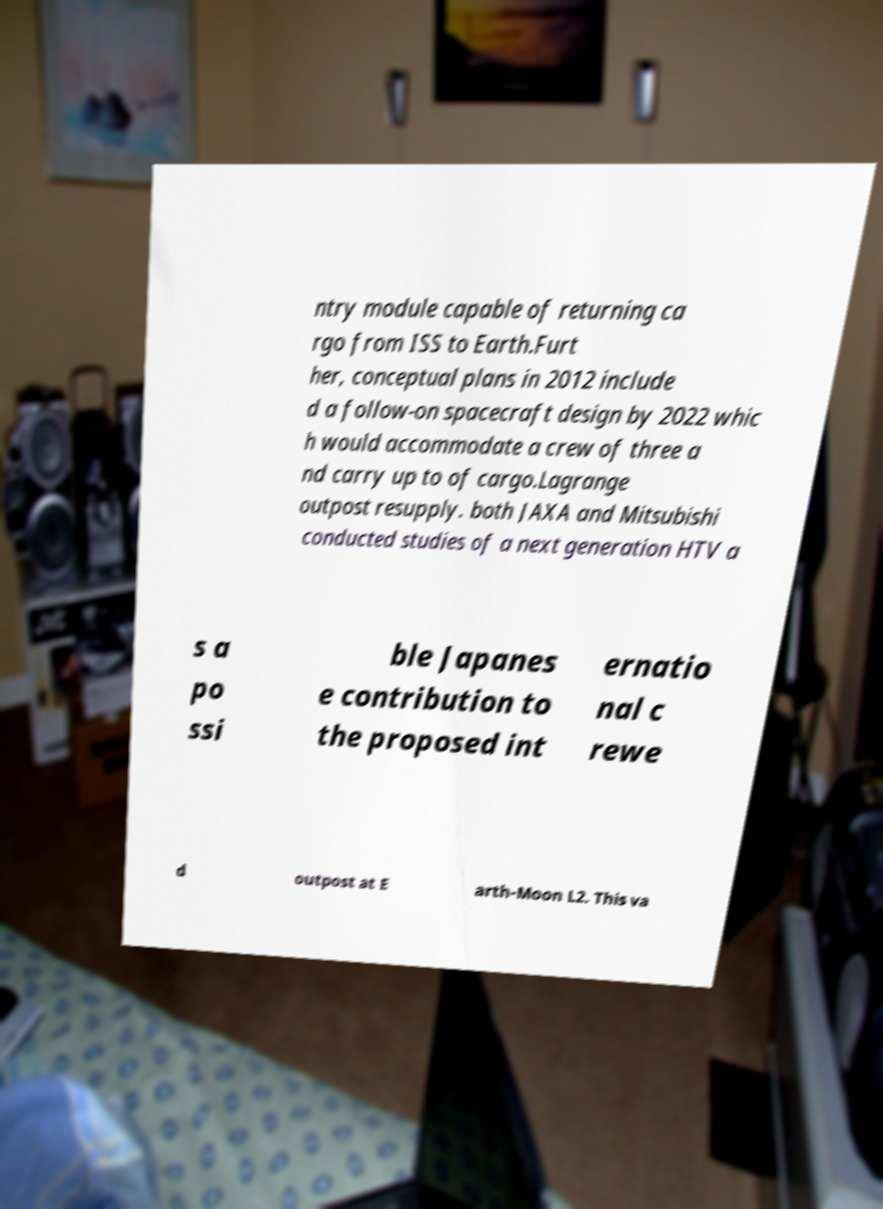Please read and relay the text visible in this image. What does it say? ntry module capable of returning ca rgo from ISS to Earth.Furt her, conceptual plans in 2012 include d a follow-on spacecraft design by 2022 whic h would accommodate a crew of three a nd carry up to of cargo.Lagrange outpost resupply. both JAXA and Mitsubishi conducted studies of a next generation HTV a s a po ssi ble Japanes e contribution to the proposed int ernatio nal c rewe d outpost at E arth-Moon L2. This va 